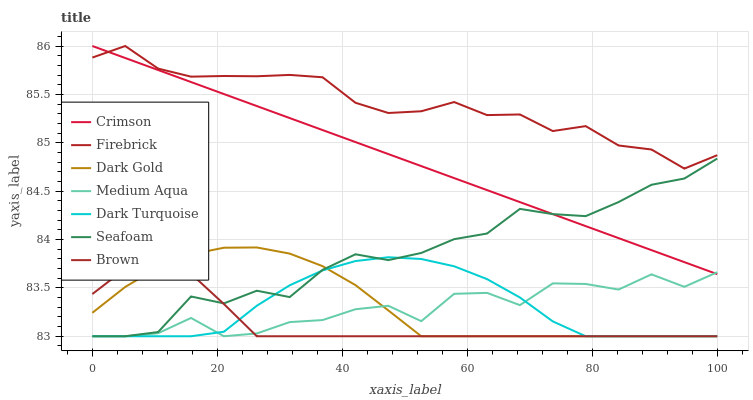Does Brown have the minimum area under the curve?
Answer yes or no. Yes. Does Firebrick have the maximum area under the curve?
Answer yes or no. Yes. Does Dark Gold have the minimum area under the curve?
Answer yes or no. No. Does Dark Gold have the maximum area under the curve?
Answer yes or no. No. Is Crimson the smoothest?
Answer yes or no. Yes. Is Medium Aqua the roughest?
Answer yes or no. Yes. Is Dark Gold the smoothest?
Answer yes or no. No. Is Dark Gold the roughest?
Answer yes or no. No. Does Brown have the lowest value?
Answer yes or no. Yes. Does Firebrick have the lowest value?
Answer yes or no. No. Does Crimson have the highest value?
Answer yes or no. Yes. Does Dark Gold have the highest value?
Answer yes or no. No. Is Dark Gold less than Crimson?
Answer yes or no. Yes. Is Firebrick greater than Medium Aqua?
Answer yes or no. Yes. Does Dark Turquoise intersect Dark Gold?
Answer yes or no. Yes. Is Dark Turquoise less than Dark Gold?
Answer yes or no. No. Is Dark Turquoise greater than Dark Gold?
Answer yes or no. No. Does Dark Gold intersect Crimson?
Answer yes or no. No. 